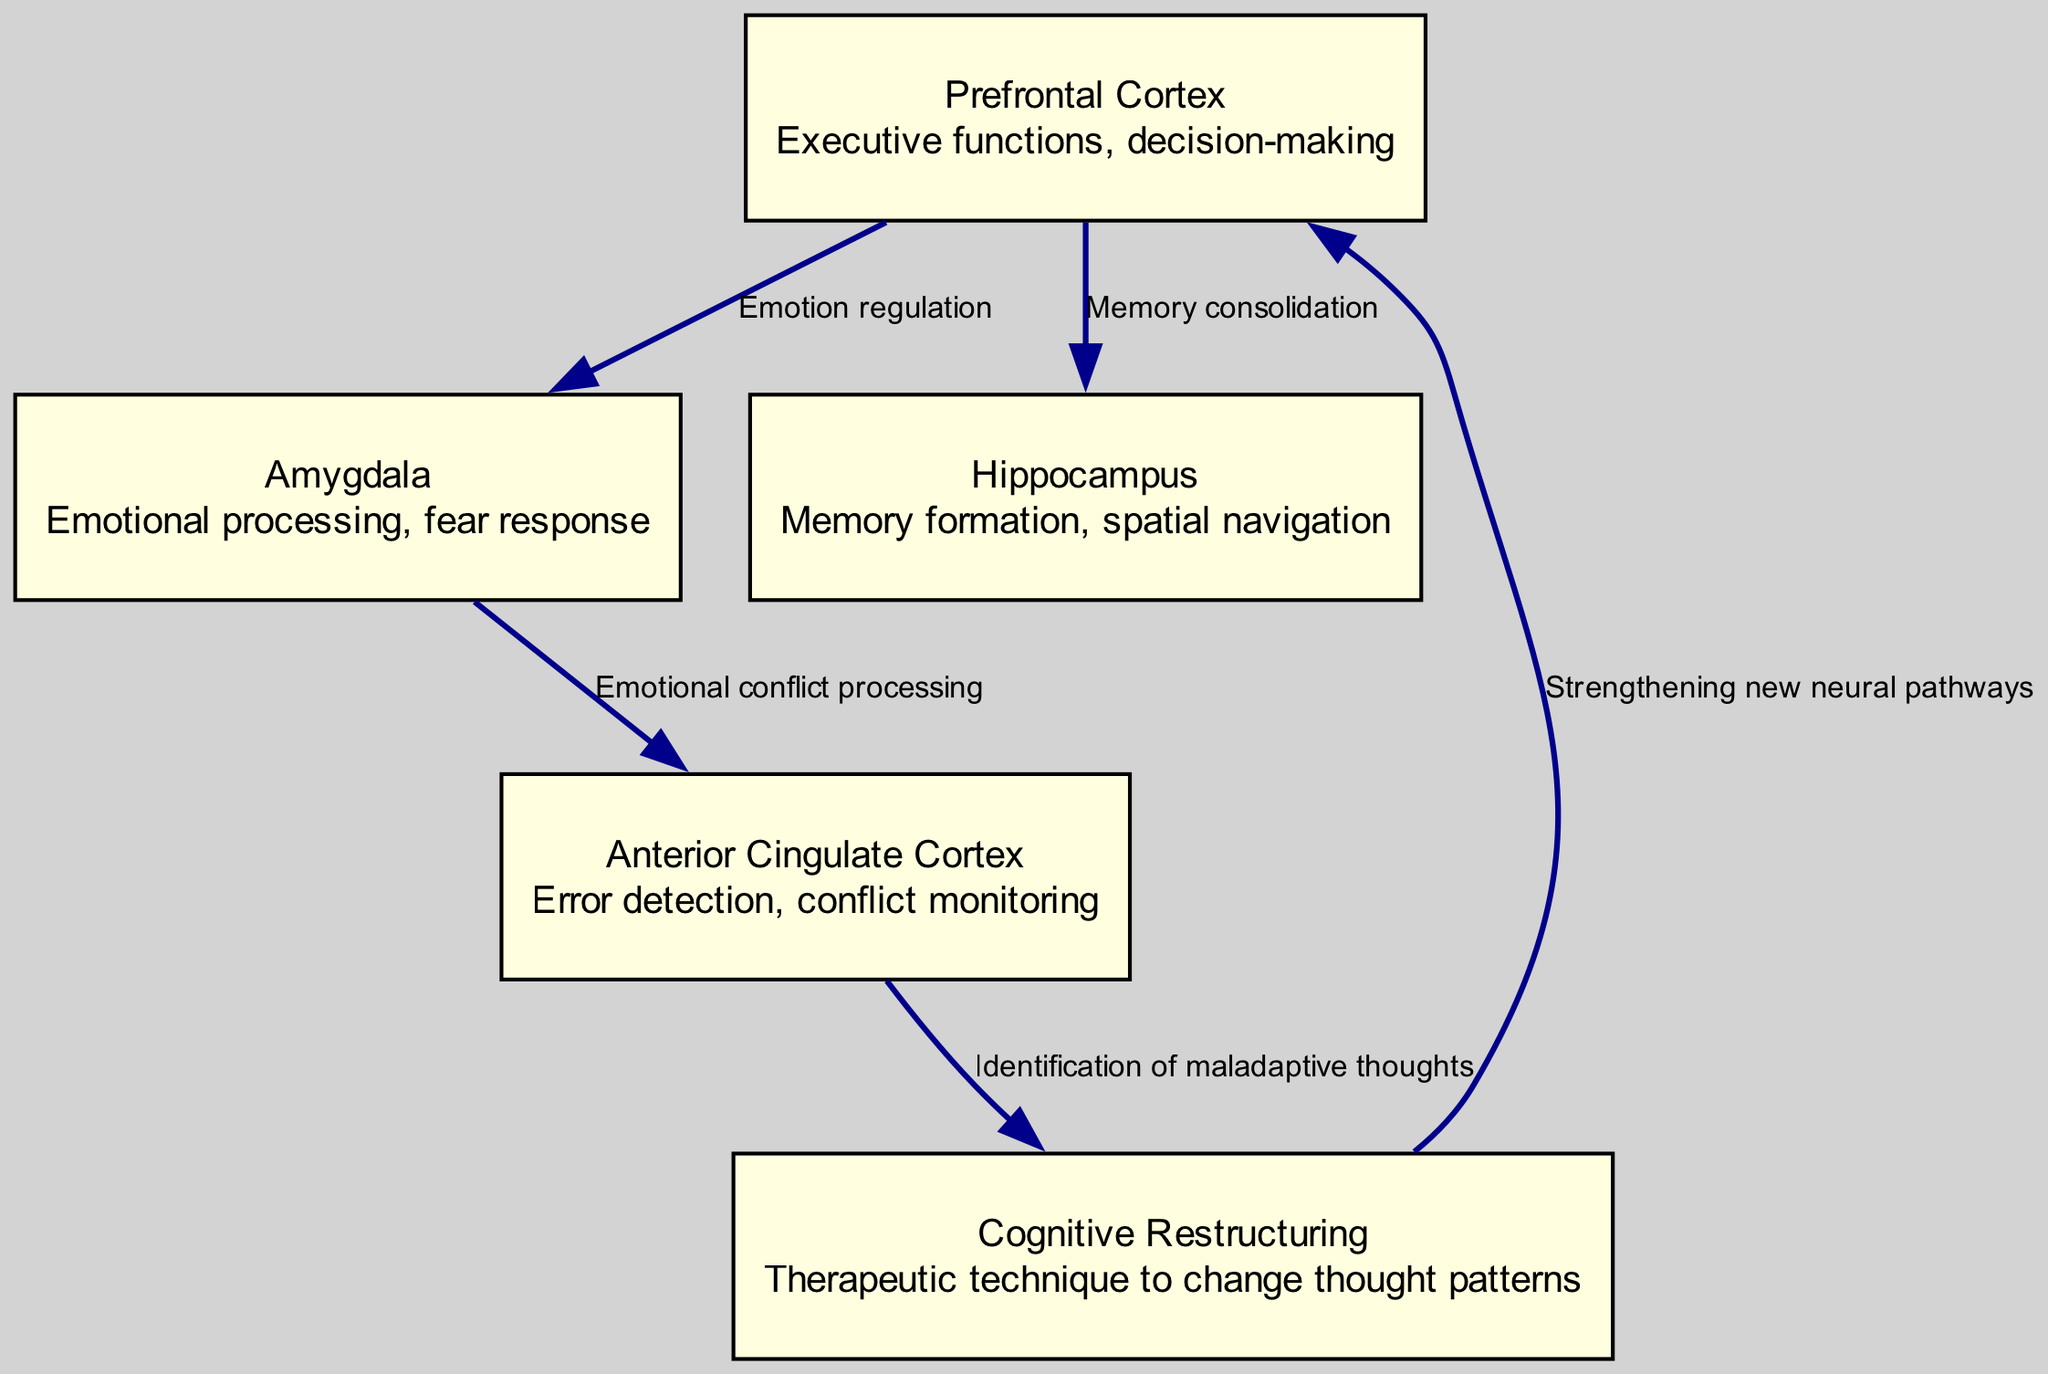What are the nodes present in the diagram? The nodes listed in the diagram are: Prefrontal Cortex, Amygdala, Hippocampus, Anterior Cingulate Cortex, Cognitive Restructuring. This information can be found directly from the data provided for nodes in the diagram.
Answer: Prefrontal Cortex, Amygdala, Hippocampus, Anterior Cingulate Cortex, Cognitive Restructuring How many edges connect the nodes in the diagram? To determine the number of edges, we count the entries in the edges section of the data. There are a total of 5 connections (edges) listed.
Answer: 5 Which brain region is associated with emotional processing? The description of the nodes indicates that the Amygdala is specifically linked with emotional processing and fear response. This information is found directly within the details of the node labeled "Amygdala."
Answer: Amygdala What is the role of Cognitive Restructuring in this diagram? The diagram states that Cognitive Restructuring is a therapeutic technique designed to change thought patterns. This is derived directly from its description within the nodes.
Answer: Change thought patterns Which node directly connects to the Prefrontal Cortex in the context of memory? According to the edges section, the edge from the Prefrontal Cortex to the Hippocampus indicates a connection specifically for memory consolidation. Therefore, the Hippocampus is the node that connects to the Prefrontal Cortex related to memory.
Answer: Hippocampus What process links the Anterior Cingulate Cortex to Cognitive Restructuring? The edge between the Anterior Cingulate Cortex and Cognitive Restructuring shows that the connection is defined by the identification of maladaptive thoughts. Therefore, this process represents the transition from identifying issues to restructuring thoughts.
Answer: Identification of maladaptive thoughts What type of regulation is shown between the Prefrontal Cortex and Amygdala? The diagram illustrates that the relationship between the Prefrontal Cortex and the Amygdala is labeled as "Emotion regulation." This can be directly found in the edge description linking these two nodes.
Answer: Emotion regulation How does Cognitive Restructuring affect the Prefrontal Cortex? The diagram indicates that Cognitive Restructuring leads to the strengthening of new neural pathways in the Prefrontal Cortex. This relationship is established through the edge labeled with the transition from Cognitive Restructuring to the Prefrontal Cortex.
Answer: Strengthening new neural pathways What is the main functionality of the Anterior Cingulate Cortex according to the diagram? The description provided in the node for the Anterior Cingulate Cortex mentions its functions as error detection and conflict monitoring, summarizing its main responsibilities as it relates to the process shown in the diagram.
Answer: Error detection, conflict monitoring 